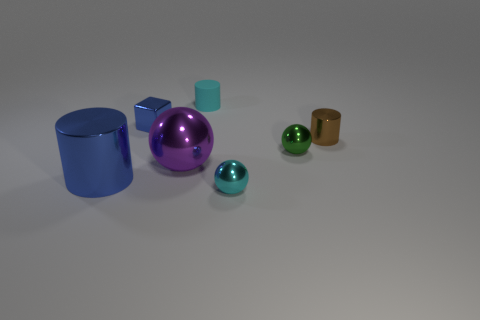Subtract all yellow cylinders. Subtract all blue cubes. How many cylinders are left? 3 Subtract all blue cubes. How many green cylinders are left? 0 Add 7 things. How many big browns exist? 0 Subtract all rubber things. Subtract all purple spheres. How many objects are left? 5 Add 6 cyan cylinders. How many cyan cylinders are left? 7 Add 2 small yellow matte balls. How many small yellow matte balls exist? 2 Add 1 green metallic spheres. How many objects exist? 8 Subtract all brown cylinders. How many cylinders are left? 2 Subtract all cyan metal spheres. How many spheres are left? 2 Subtract 0 yellow cubes. How many objects are left? 7 